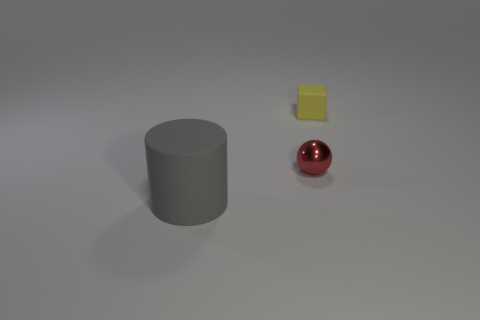Add 1 large cylinders. How many objects exist? 4 Subtract all cylinders. How many objects are left? 2 Subtract all big matte objects. Subtract all metal spheres. How many objects are left? 1 Add 3 large gray cylinders. How many large gray cylinders are left? 4 Add 2 tiny matte spheres. How many tiny matte spheres exist? 2 Subtract 0 brown balls. How many objects are left? 3 